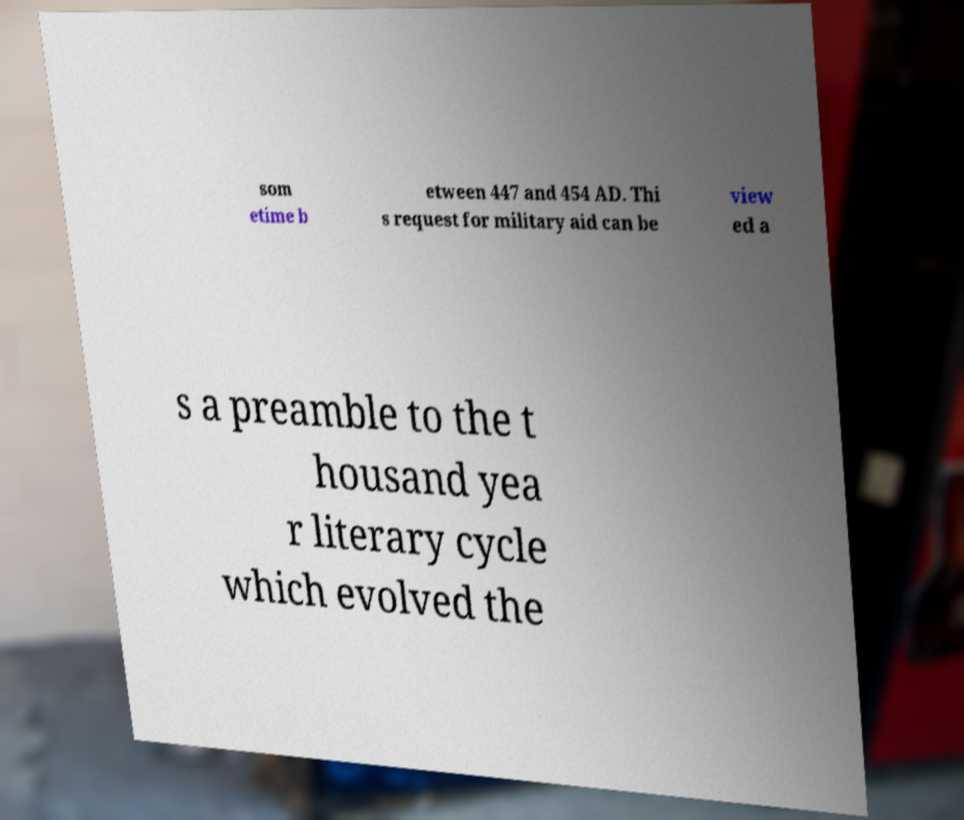Can you accurately transcribe the text from the provided image for me? som etime b etween 447 and 454 AD. Thi s request for military aid can be view ed a s a preamble to the t housand yea r literary cycle which evolved the 